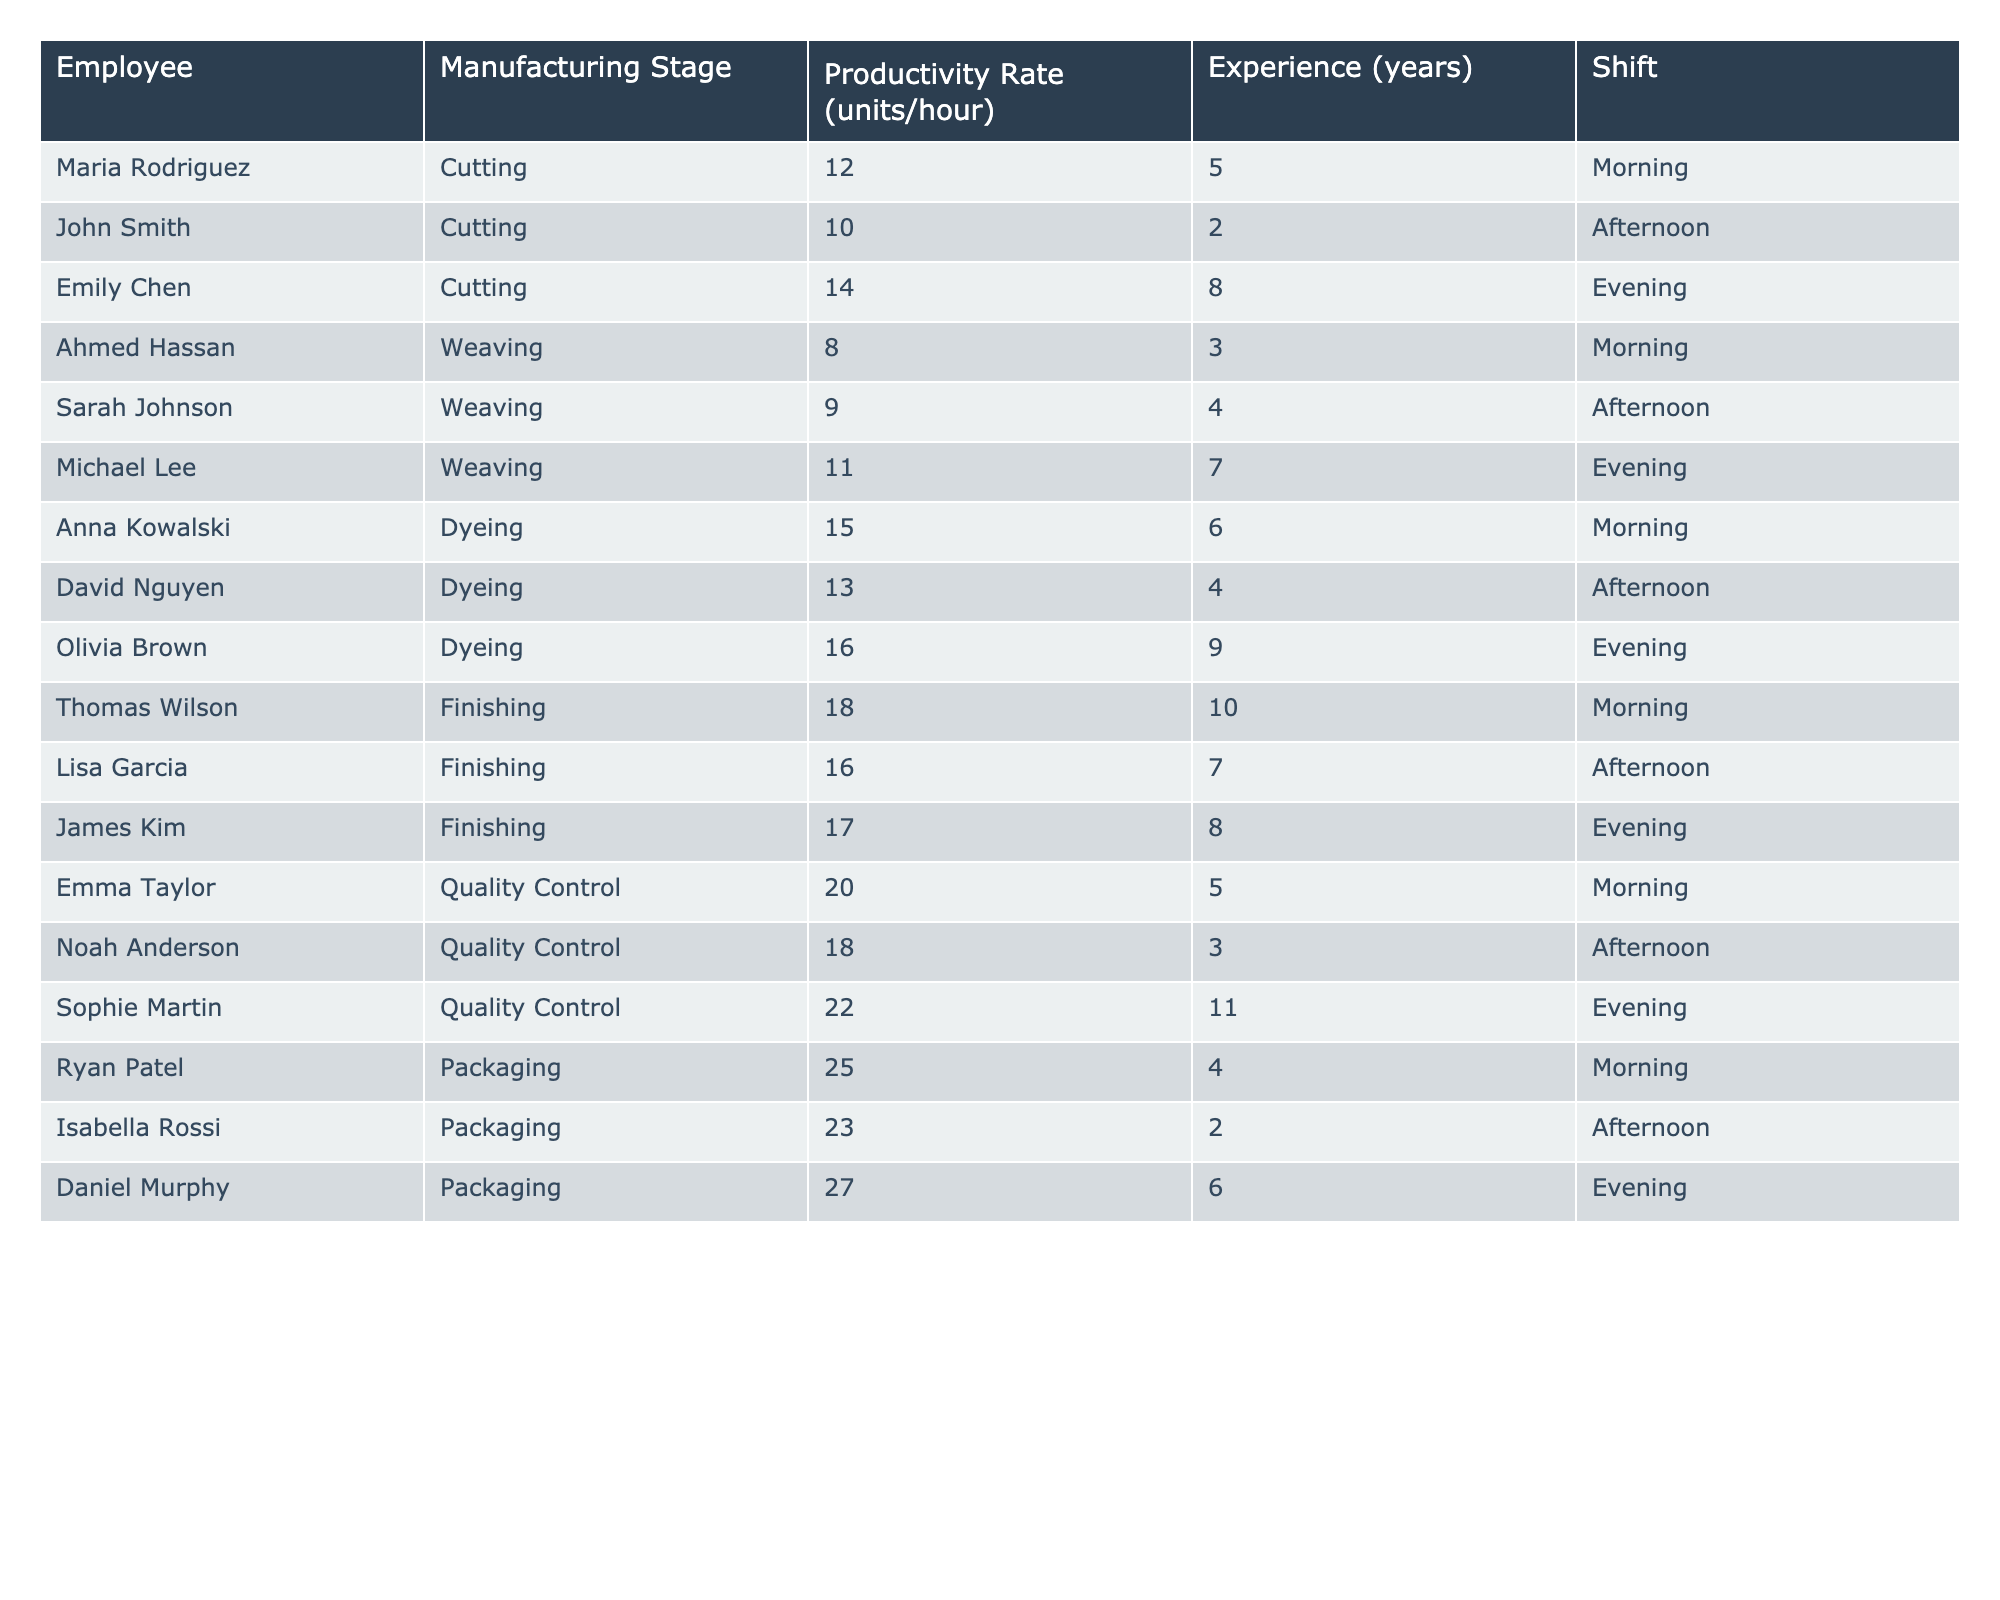What is the productivity rate of the employee with the highest productivity in the Packaging stage? In the Packaging stage, Daniel Murphy has the highest productivity rate at 27 units per hour.
Answer: 27 Who has the highest experience among the employees in the Dyeing stage? In the Dyeing stage, Olivia Brown has the most experience with 9 years.
Answer: Olivia Brown What is the average productivity rate across all employees in the Cutting stage? The productivity rates for the Cutting stage are 12, 10, and 14. The average is (12 + 10 + 14) / 3 = 12 units per hour.
Answer: 12 Is there an employee in the Weaving stage who has a productivity rate higher than 10 units/hour? Yes, both Michael Lee (11 units/hour) and Sarah Johnson (9 units/hour) have rates, and only Michael Lee exceeds 10 units.
Answer: Yes Which shift has the highest average productivity rate, and what is that rate? The average productivity for each shift is: Morning - (12 + 8 + 15 + 18 + 20 + 25) / 6 = 16.33, Afternoon - (10 + 9 + 13 + 16 + 18 + 23) / 6 = 14.83, Evening - (14 + 11 + 16 + 17 + 22 + 27) / 6 = 18.5. The Evening shift has the highest average at 18.5.
Answer: Evening shift, 18.5 What is the total productivity rate of all employees in the Finishing stage? In the Finishing stage, the rates are 18, 16, and 17. Summing these gives 18 + 16 + 17 = 51 units/hour total.
Answer: 51 Which employee in Quality Control has the lowest productivity rate, and what is it? In Quality Control, Noah Anderson has the lowest productivity rate of 18 units/hour.
Answer: Noah Anderson, 18 How many employees have a productivity rate greater than 15 units/hour? The employees with rates above 15 units/hour are Anna Kowalski, Olivia Brown, Thomas Wilson, Sophie Martin, Ryan Patel, and Daniel Murphy, totaling 6 employees.
Answer: 6 Is there any employee in the Cutting stage with more than 6 years of experience? Yes, Emily Chen has 8 years of experience in the Cutting stage.
Answer: Yes What is the range of productivity rates for employees in the Weaving stage? The productivity rates in the Weaving stage are 8, 9, and 11. The range is 11 - 8 = 3 units/hour.
Answer: 3 Which employee has the highest productivity rate overall, and in which stage do they work? Ryan Patel has the highest productivity rate of 25 units/hour and works in the Packaging stage.
Answer: Ryan Patel, Packaging 